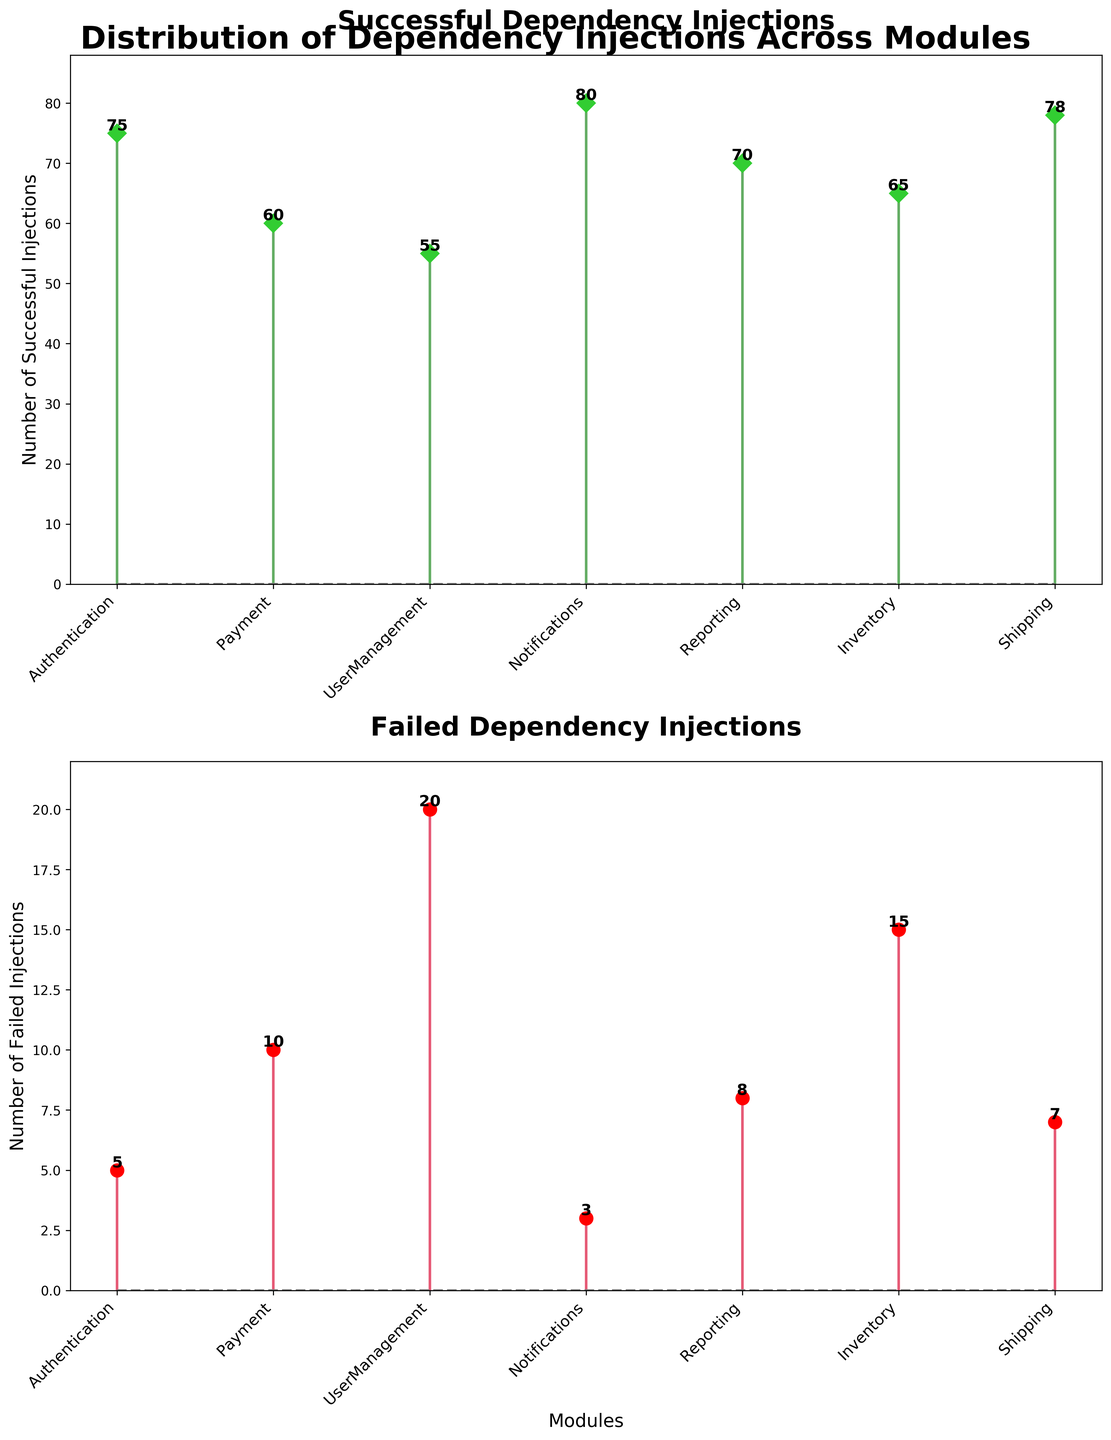What is the title of the first subplot? The first subplot's title is written at the top of the subplot which is in bold. It clearly states "Successful Dependency Injections".
Answer: Successful Dependency Injections Which module has the highest number of successful injections? The highest value in the 'Successful Dependency Injections' subplot is visualized with a maximum stem height. The module corresponding to the tallest stem is 'Notifications' with 80 successful injections.
Answer: Notifications What is the total number of failed injections for all modules combined? Adding up all the failed injections from each module: 5 (Authentication) + 10 (Payment) + 20 (UserManagement) + 3 (Notifications) + 8 (Reporting) + 15 (Inventory) + 7 (Shipping). The total is 68.
Answer: 68 How many more successful injections does the Authentication module have compared to the Payment module? The number of successful injections for Authentication is 75, and for Payment, it is 60. The difference is calculated by subtracting 60 from 75.
Answer: 15 Which module has the smallest number of failed injections? The smallest number of failed injections is represented by the shortest stem in the 'Failed Dependency Injections' subplot, which is found in the 'Notifications' module with 3 failed injections.
Answer: Notifications What are the x-axis labels for both subplots? The x-axis labels for both subplots represent the modules and are 'Authentication', 'Payment', 'UserManagement', 'Notifications', 'Reporting', 'Inventory', 'Shipping'. These are positioned at an angle for better visibility.
Answer: Authentication, Payment, UserManagement, Notifications, Reporting, Inventory, Shipping How much higher is the number of successful injections in the Shipping module compared to the Inventory module? The Shipping module has 78 successful injections, and the Inventory module has 65. The difference is obtained by subtracting 65 from 78.
Answer: 13 Which module shows a greater discrepancy between successful and failed injections: UserManagement or Shipping? Calculate the difference between successful and failed injections for each module:
- UserManagement: 55 (successful) - 20 (failed) = 35
- Shipping: 78 (successful) - 7 (failed) = 71
The greater discrepancy is for the Shipping module.
Answer: Shipping What color represents the stems in the 'Failed Dependency Injections' subplot? The stems in the 'Failed Dependency Injections' subplot are represented in the color red.
Answer: Red What is the y-axis label for the 'Successful Dependency Injections' subplot? The y-axis label for the 'Successful Dependency Injections' subplot is "Number of Successful Injections".
Answer: Number of Successful Injections 